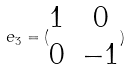<formula> <loc_0><loc_0><loc_500><loc_500>e _ { 3 } = ( \begin{matrix} 1 & 0 \\ 0 & - 1 \end{matrix} )</formula> 